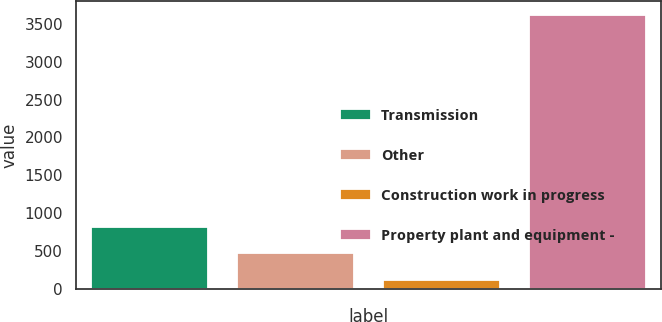Convert chart. <chart><loc_0><loc_0><loc_500><loc_500><bar_chart><fcel>Transmission<fcel>Other<fcel>Construction work in progress<fcel>Property plant and equipment -<nl><fcel>821.6<fcel>471.8<fcel>122<fcel>3620<nl></chart> 